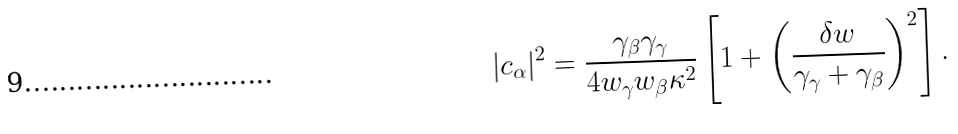<formula> <loc_0><loc_0><loc_500><loc_500>| c _ { \alpha } | ^ { 2 } = \frac { \gamma _ { \beta } \gamma _ { \gamma } } { 4 w _ { \gamma } w _ { \beta } \kappa ^ { 2 } } \left [ 1 + \left ( \frac { \delta w } { \gamma _ { \gamma } + \gamma _ { \beta } } \right ) ^ { 2 } \right ] .</formula> 